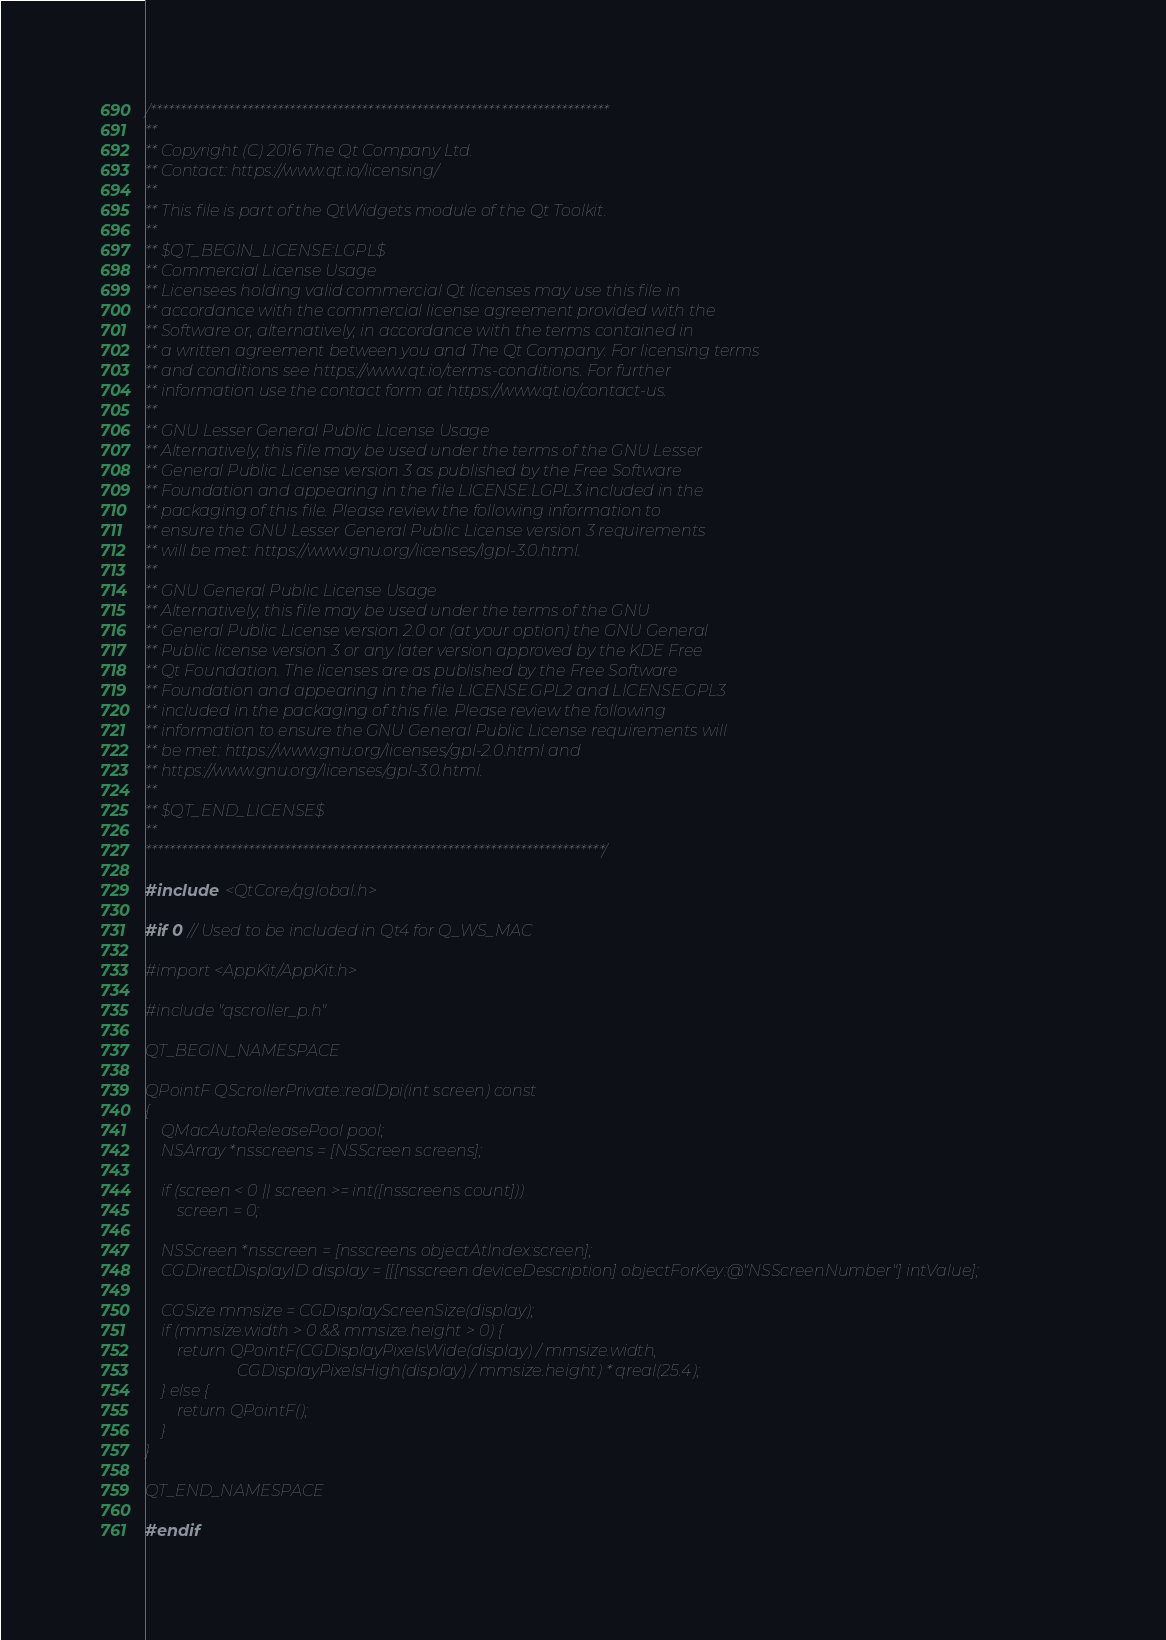<code> <loc_0><loc_0><loc_500><loc_500><_ObjectiveC_>/****************************************************************************
**
** Copyright (C) 2016 The Qt Company Ltd.
** Contact: https://www.qt.io/licensing/
**
** This file is part of the QtWidgets module of the Qt Toolkit.
**
** $QT_BEGIN_LICENSE:LGPL$
** Commercial License Usage
** Licensees holding valid commercial Qt licenses may use this file in
** accordance with the commercial license agreement provided with the
** Software or, alternatively, in accordance with the terms contained in
** a written agreement between you and The Qt Company. For licensing terms
** and conditions see https://www.qt.io/terms-conditions. For further
** information use the contact form at https://www.qt.io/contact-us.
**
** GNU Lesser General Public License Usage
** Alternatively, this file may be used under the terms of the GNU Lesser
** General Public License version 3 as published by the Free Software
** Foundation and appearing in the file LICENSE.LGPL3 included in the
** packaging of this file. Please review the following information to
** ensure the GNU Lesser General Public License version 3 requirements
** will be met: https://www.gnu.org/licenses/lgpl-3.0.html.
**
** GNU General Public License Usage
** Alternatively, this file may be used under the terms of the GNU
** General Public License version 2.0 or (at your option) the GNU General
** Public license version 3 or any later version approved by the KDE Free
** Qt Foundation. The licenses are as published by the Free Software
** Foundation and appearing in the file LICENSE.GPL2 and LICENSE.GPL3
** included in the packaging of this file. Please review the following
** information to ensure the GNU General Public License requirements will
** be met: https://www.gnu.org/licenses/gpl-2.0.html and
** https://www.gnu.org/licenses/gpl-3.0.html.
**
** $QT_END_LICENSE$
**
****************************************************************************/

#include <QtCore/qglobal.h>

#if 0 // Used to be included in Qt4 for Q_WS_MAC

#import <AppKit/AppKit.h>

#include "qscroller_p.h"

QT_BEGIN_NAMESPACE

QPointF QScrollerPrivate::realDpi(int screen) const
{
    QMacAutoReleasePool pool;
    NSArray *nsscreens = [NSScreen screens];

    if (screen < 0 || screen >= int([nsscreens count]))
        screen = 0;

    NSScreen *nsscreen = [nsscreens objectAtIndex:screen];
    CGDirectDisplayID display = [[[nsscreen deviceDescription] objectForKey:@"NSScreenNumber"] intValue];

    CGSize mmsize = CGDisplayScreenSize(display);
    if (mmsize.width > 0 && mmsize.height > 0) {
        return QPointF(CGDisplayPixelsWide(display) / mmsize.width,
                       CGDisplayPixelsHigh(display) / mmsize.height) * qreal(25.4);
    } else {
        return QPointF();
    }
}

QT_END_NAMESPACE

#endif
</code> 